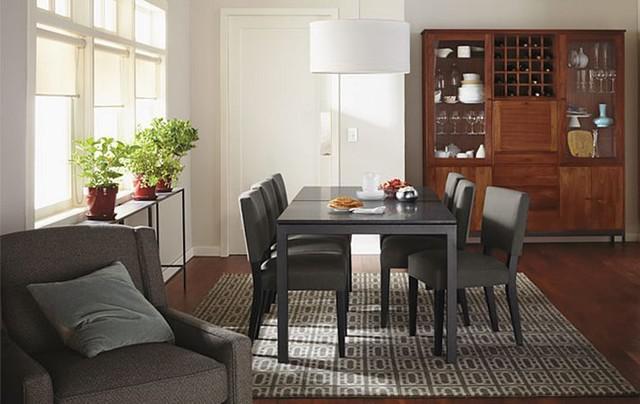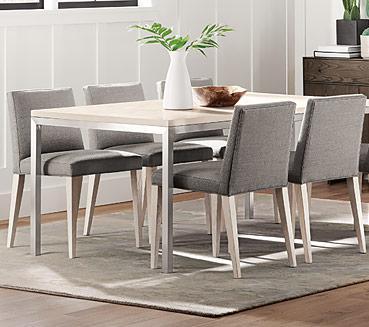The first image is the image on the left, the second image is the image on the right. For the images shown, is this caption "There are three windows on the left wall in the image on the left." true? Answer yes or no. Yes. 